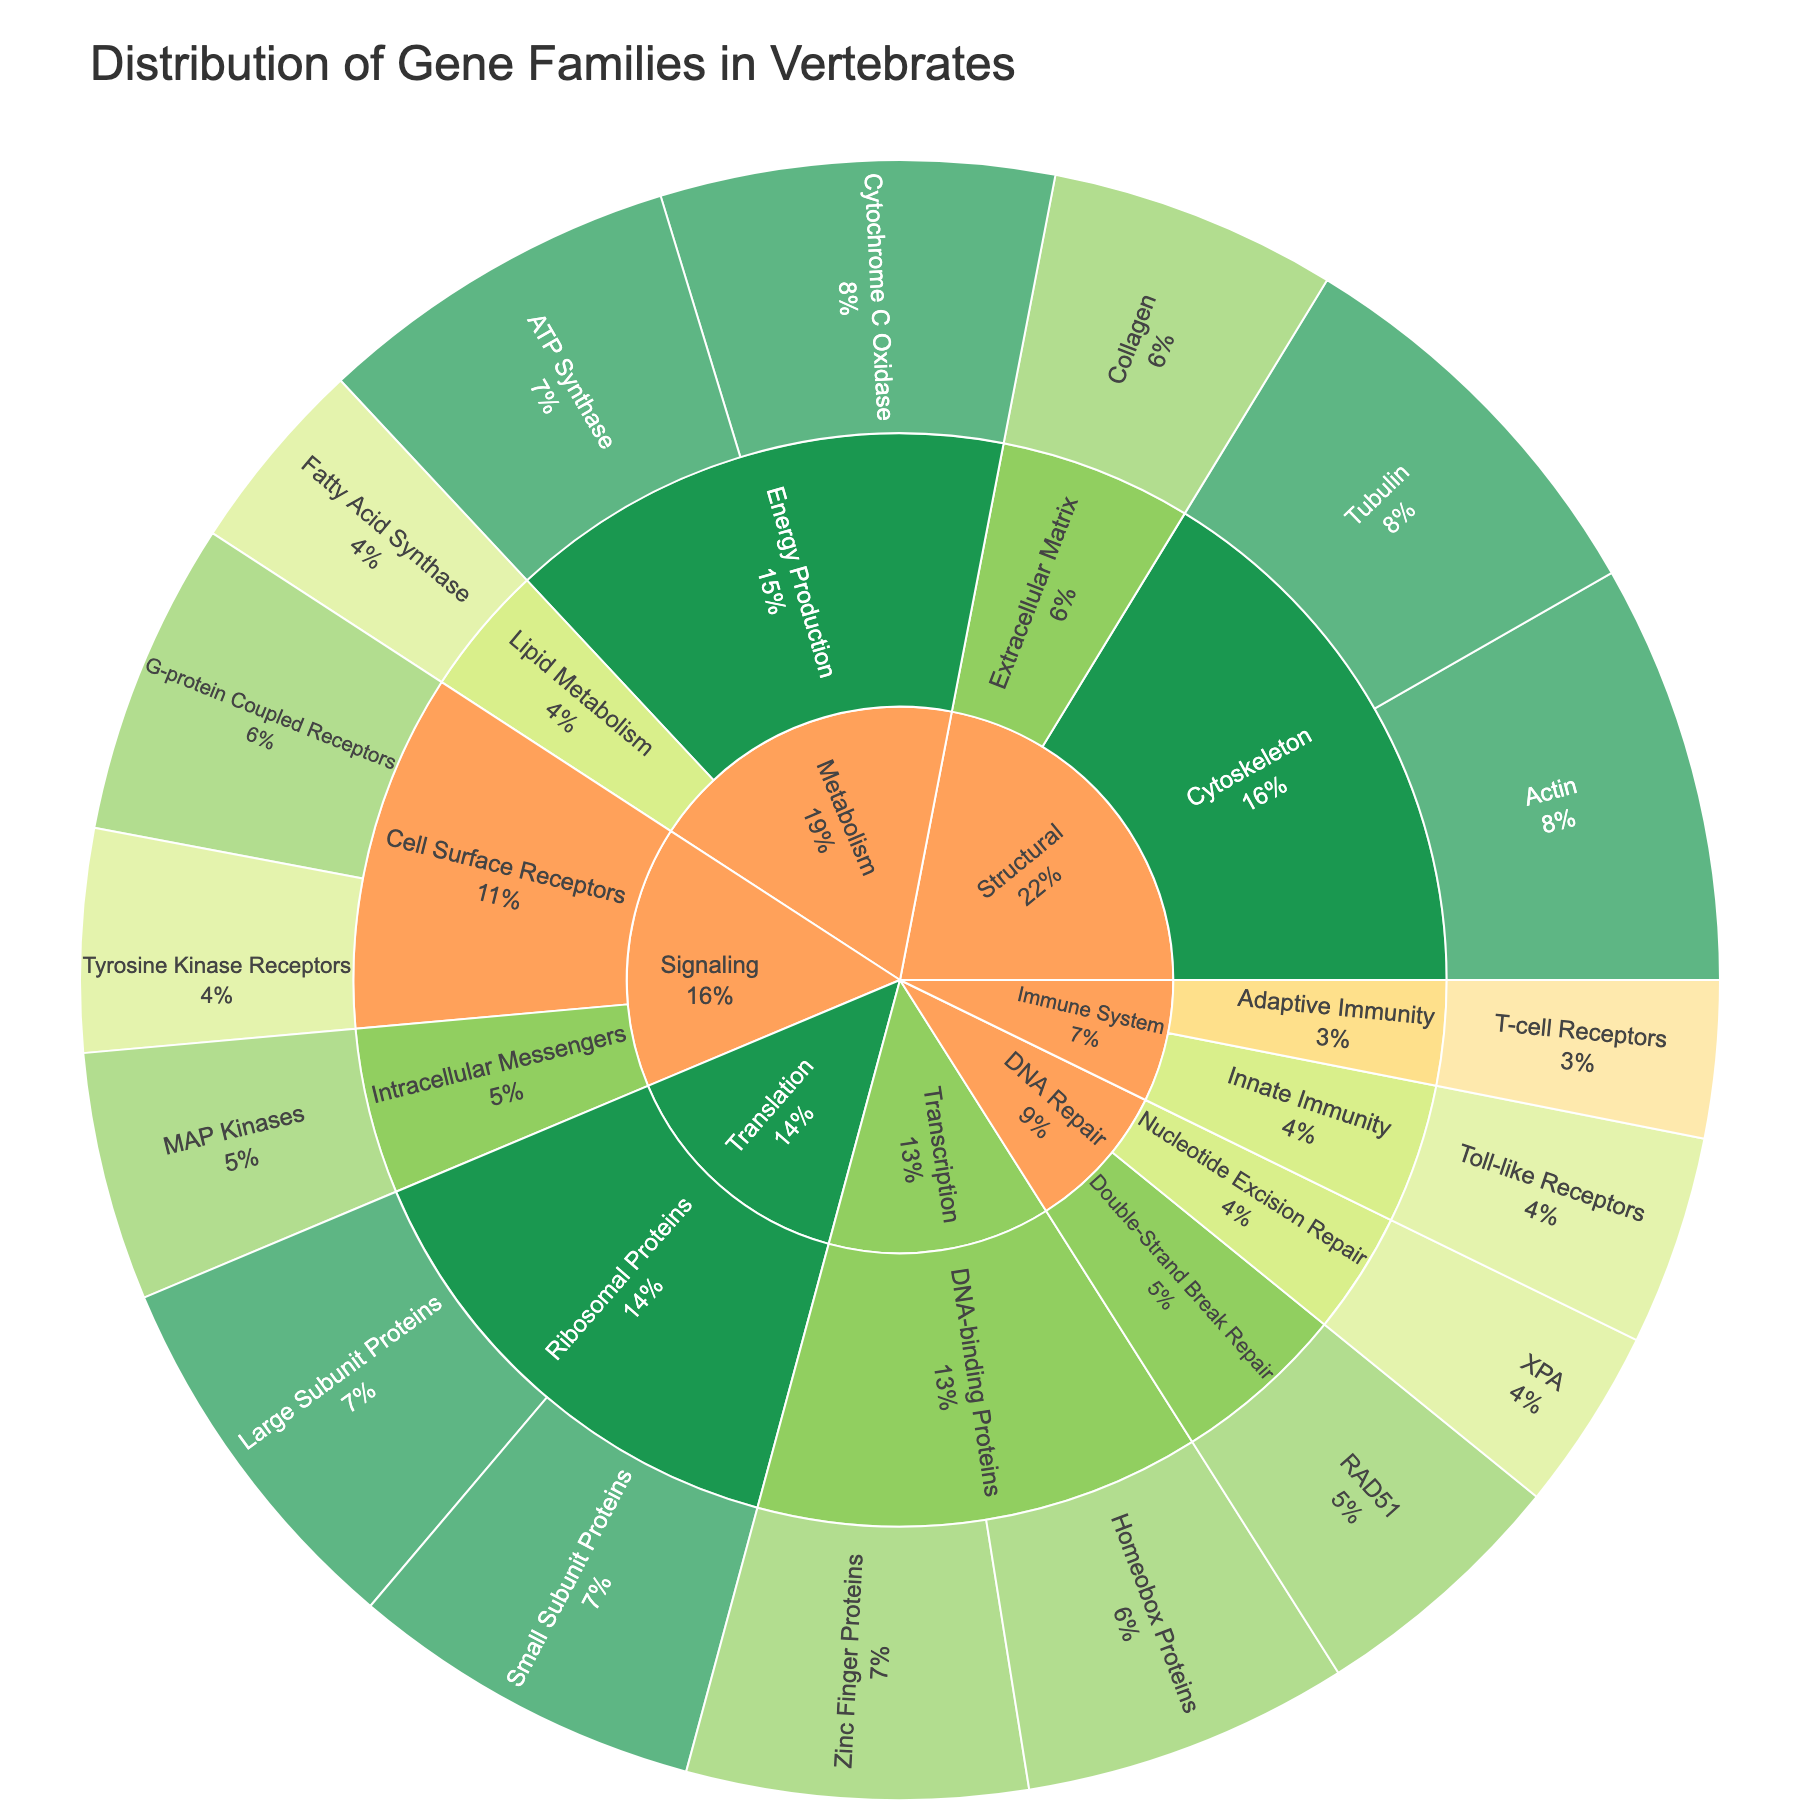what category has the highest number of very high conservation gene families? By observing the colors representing "Very High" conservation, it is clear that "Structural" has three very high conservation gene families, namely Actin and Tubulin under Cytoskeleton, and Collagen under Extracellular Matrix.
Answer: Structural which gene family under the Metabolism category has the highest value? Within the Metabolism category, we look at the individual gene families and their values. Cytochrome C Oxidase has a value of 150, which is the highest.
Answer: Cytochrome C Oxidase how many gene families with high conservation are present in the Signaling category? Within the Signaling category, we observe the gene families with the "High" conservation color. G-protein Coupled Receptors and MAP Kinases show high conservation. Therefore, there are two gene families with high conservation.
Answer: 2 which subcategory in the Translation category contains more gene families, the Large Subunit Proteins or Small Subunit Proteins? By looking at the Translation category and comparing its subcategories, we see that both the Large Subunit Proteins and Small Subunit Proteins each have one gene family. Hence, they contain an equal number of gene families.
Answer: They are equal what is the total value of gene families with medium conservation in Innate Immunity and Cell Surface Receptors subcategories? We need to sum up the values of gene families with medium conservation in the subcategories Innate Immunity and Cell Surface Receptors. Toll-like Receptors have a value of 80 and Tyrosine Kinase Receptors have a value of 85. So, 80 + 85 = 165.
Answer: 165 which category has the least number of subcategories? Observing all categories, DNA Repair has only one subcategory, the smallest number in comparison to the other categories.
Answer: DNA Repair what proportion of genes in the Structural category are under the cytoskeleton subcategory? We consider the values for the cytoskeleton’s gene families (Actin and Tubulin, totaling 160 + 155 = 315) and those in the entire Structural category (Actin, Tubulin, and Collagen, summing up to 160 + 155 + 110 = 425). The proportion is 315/425, which simplifies to approximately 0.741 or 74.1%.
Answer: 74.1% which has a higher value, the large subunit proteins or small subunit proteins in the translation category? Within the Translation category, comparing the Large Subunit Proteins (value 145) to Small Subunit Proteins (value 135), Large Subunit Proteins have a higher value.
Answer: Large Subunit Proteins what's the difference between the highest and the lowest values within the DNA Repair category? Observing the values in the DNA Repair category, RAD51 has 100 and XPA has 70. The difference between them is 100 - 70 = 30.
Answer: 30 what is the proportion of high conservation gene families in the Signaling category compared to the total number of high conservation gene families in the chart? Signaling has two gene families with high conservation (G-protein Coupled Receptors and MAP Kinases). The total number of high conservation gene families in the entire chart includes those in Signaling (2) plus Collagen in Structural (1), Zinc Finger Proteins and Homeobox Proteins in Transcription (2), and RAD51 in DNA Repair (1), summing up to 6. The proportion is 2/6, which simplifies to 1/3 or approximately 33.3%.
Answer: 33.3% 